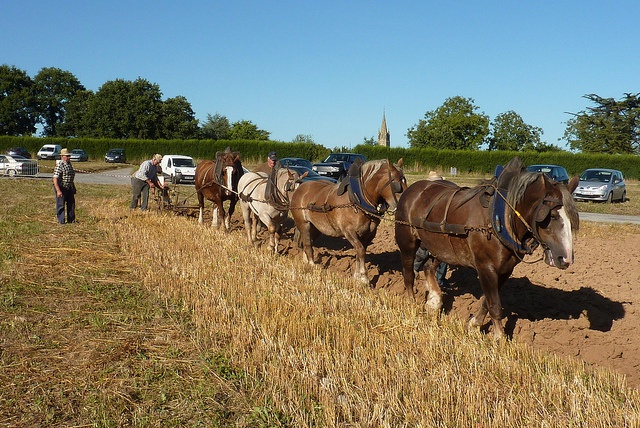Describe the objects in this image and their specific colors. I can see horse in gray, maroon, and black tones, car in gray, black, and darkgray tones, people in gray, black, and maroon tones, people in gray, black, and lightgray tones, and car in gray, black, navy, and darkgray tones in this image. 